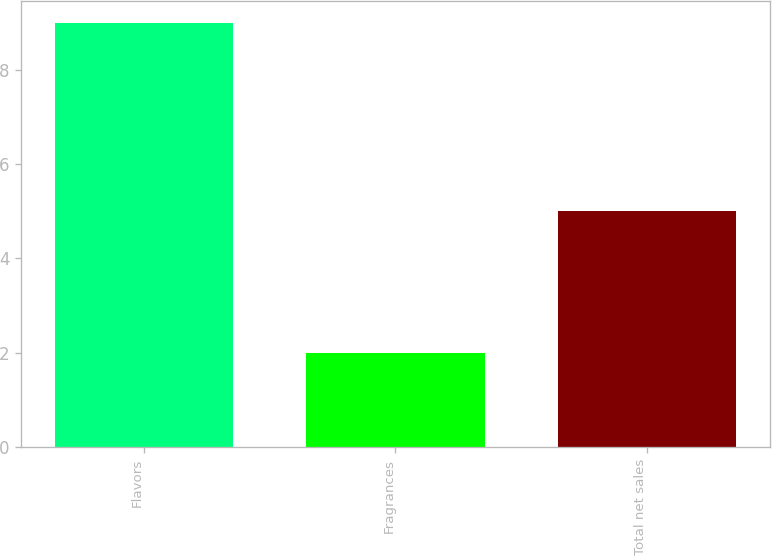<chart> <loc_0><loc_0><loc_500><loc_500><bar_chart><fcel>Flavors<fcel>Fragrances<fcel>Total net sales<nl><fcel>9<fcel>2<fcel>5<nl></chart> 